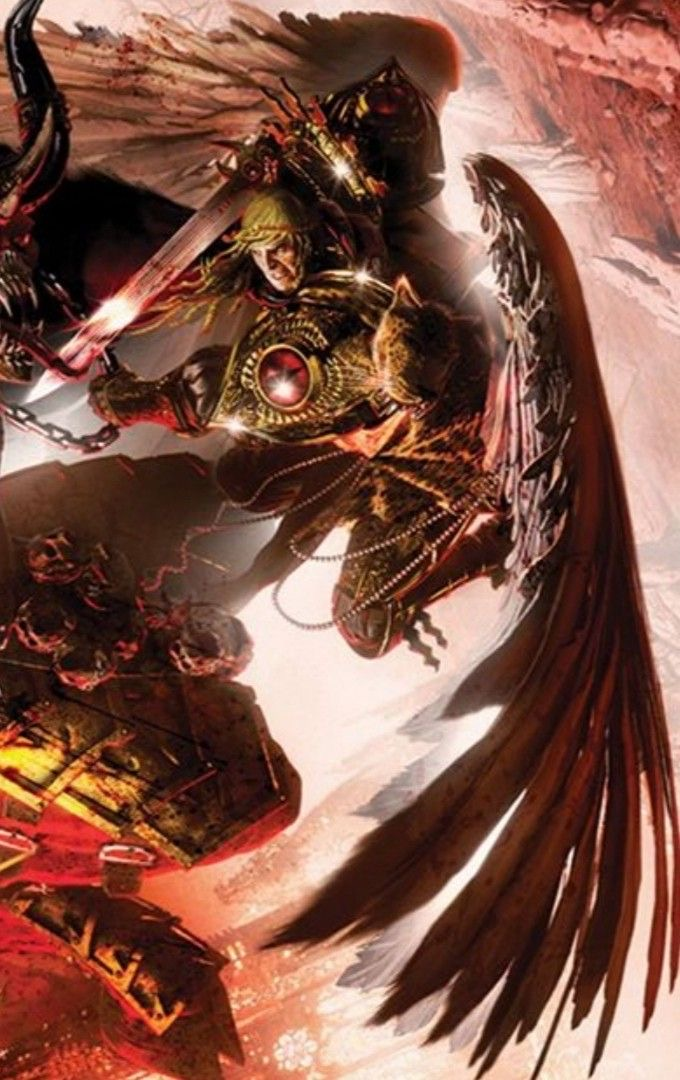Come up with a description for the content of this image (make it {extreme knowledge}, no more than 9 words!), while also describing the style of this image in detail. For the latter, look at the texture carefully to determine the techniqe used. Be specific. In that part, mention the style and exact content. Briefly describe the style as aptly as possible, don't say 'likely', make an straight forward response, giving great emphasis on the techniques used to generate such an image (dark fantasy artwork, for example, or max knowledge detail/ every exact even small details in the image), including details about how sparse/minimal or complex it is. Then provide your response in the following format, always using a | to separate the new content idea from the style descriptions: <content in the image>, | <details>, <small details>, <exact look and feel>, <colors used>. You will be inclined to say 'digital' if you're not sure, please only do that when you're certain, and go into full detail first. Armored figure with wings, glowing weapon, | The image is a digital illustration with a high level of detail, showcasing a character in elaborate fantasy armor complete with intricate patterns and embellishments. The wings are detailed with individual feathers, and the weapon emits a radiant energy, giving the impression of motion. The style is dynamic, with a blend of smooth gradients and sharp, crisp lines that create a sense of depth and three-dimensionality. The color palette is rich, dominated by warm hues of red, brown, and gold, which contrast with the cooler tones of the character's greenish facial features. The overall effect is a visually arresting piece with a dark, epic fantasy ambiance. 